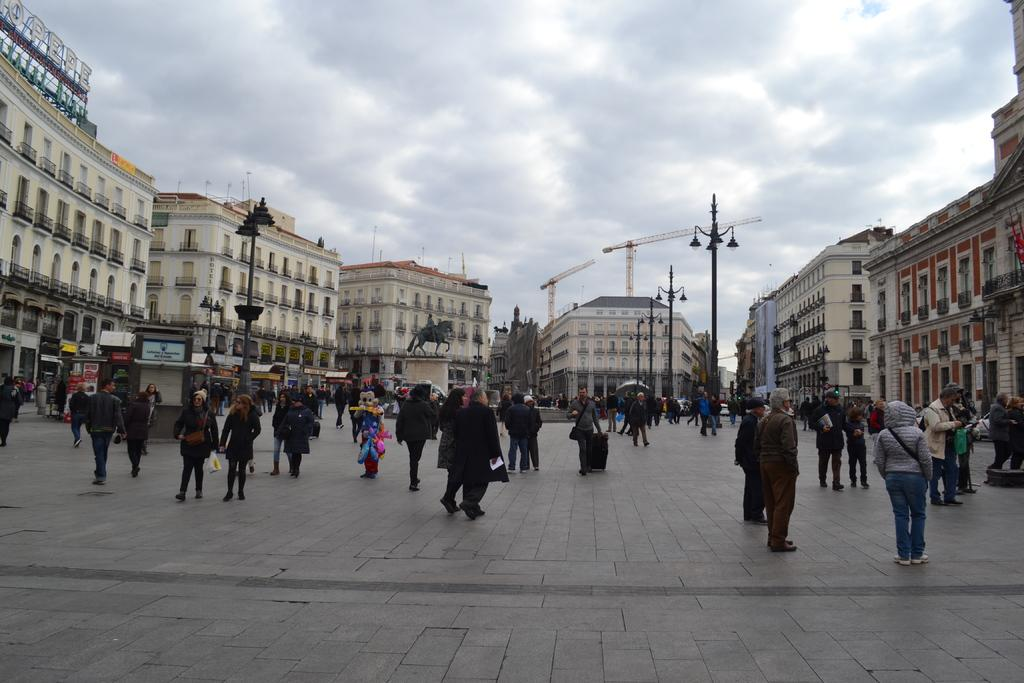What is happening on the ground in the image? There are people on the ground in the image. What can be seen in the background of the image? There is a statue, buildings, poles, and the sky visible in the background of the image. What type of stamp can be seen on the statue in the image? There is no stamp present on the statue in the image. What kind of pain are the people on the ground experiencing in the image? There is no indication of pain or discomfort for the people on the ground in the image. 